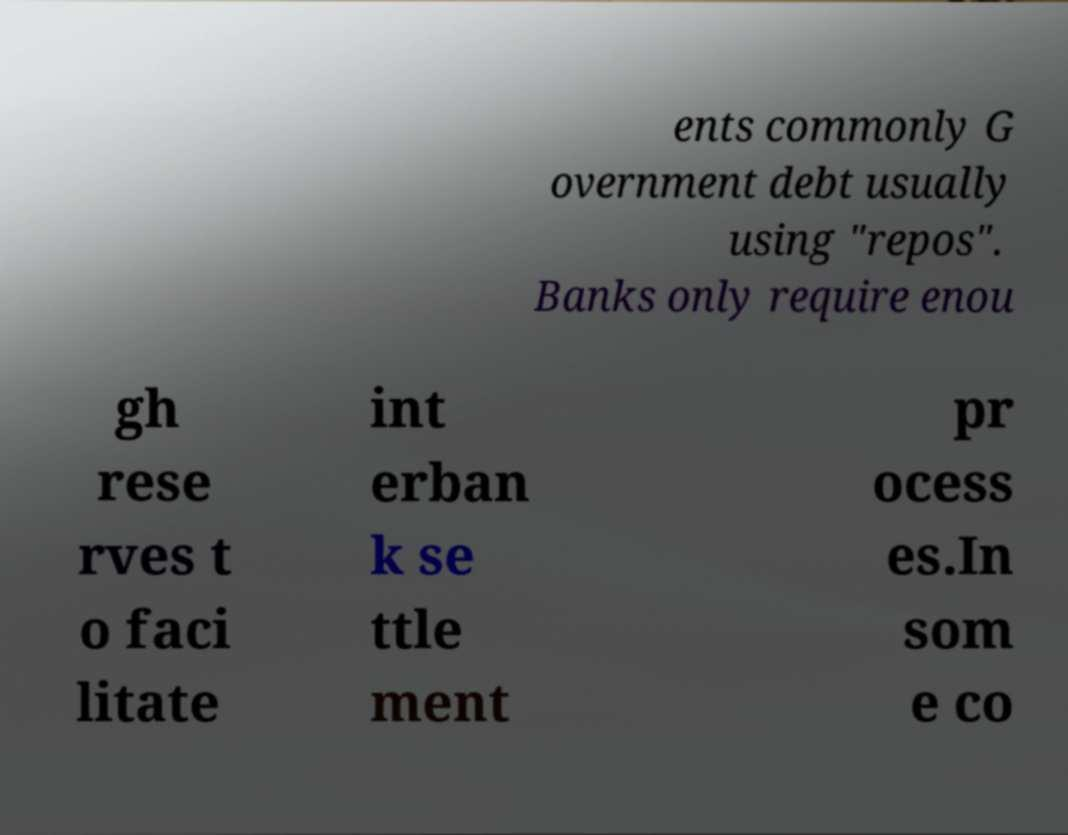There's text embedded in this image that I need extracted. Can you transcribe it verbatim? ents commonly G overnment debt usually using "repos". Banks only require enou gh rese rves t o faci litate int erban k se ttle ment pr ocess es.In som e co 